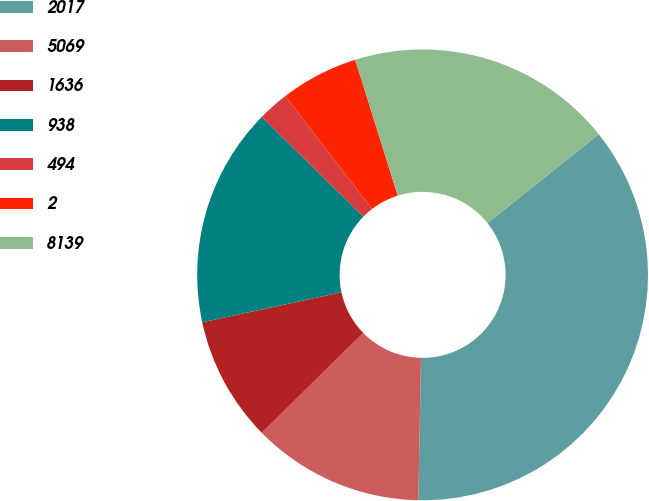Convert chart. <chart><loc_0><loc_0><loc_500><loc_500><pie_chart><fcel>2017<fcel>5069<fcel>1636<fcel>938<fcel>494<fcel>2<fcel>8139<nl><fcel>36.01%<fcel>12.35%<fcel>8.97%<fcel>15.73%<fcel>2.22%<fcel>5.59%<fcel>19.11%<nl></chart> 